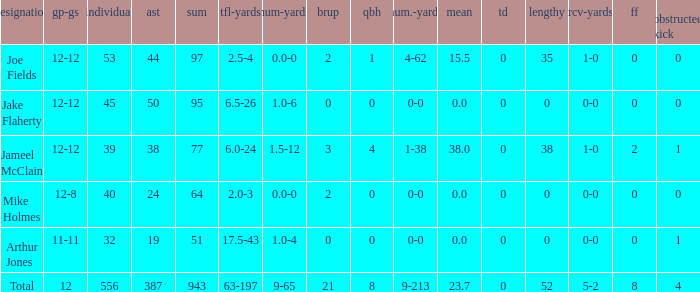How many yards for the player with tfl-yds of 2.5-4? 4-62. 